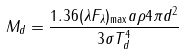<formula> <loc_0><loc_0><loc_500><loc_500>M _ { d } = \frac { 1 . 3 6 ( { \lambda } F _ { \lambda } ) _ { \max } a \rho 4 { \pi } d ^ { 2 } } { 3 { \sigma } T _ { d } ^ { 4 } }</formula> 